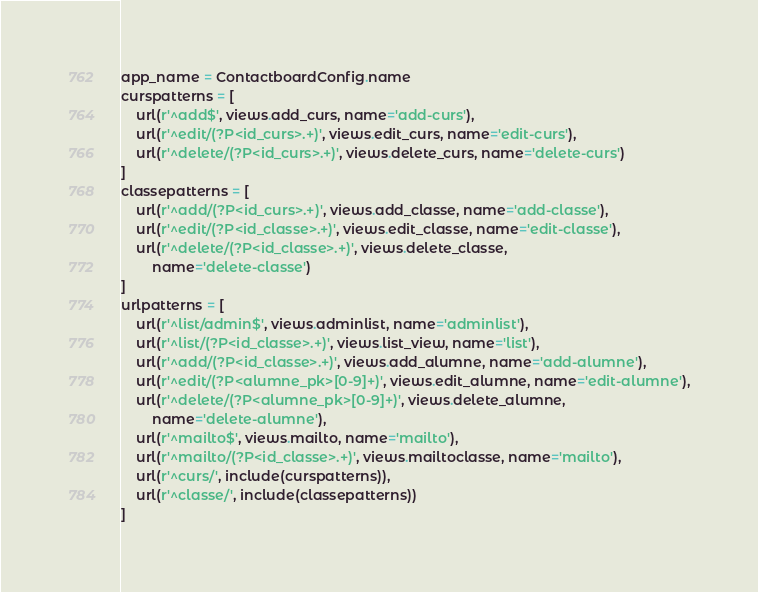Convert code to text. <code><loc_0><loc_0><loc_500><loc_500><_Python_>app_name = ContactboardConfig.name
curspatterns = [
    url(r'^add$', views.add_curs, name='add-curs'),
    url(r'^edit/(?P<id_curs>.+)', views.edit_curs, name='edit-curs'),
    url(r'^delete/(?P<id_curs>.+)', views.delete_curs, name='delete-curs')
]
classepatterns = [
    url(r'^add/(?P<id_curs>.+)', views.add_classe, name='add-classe'),
    url(r'^edit/(?P<id_classe>.+)', views.edit_classe, name='edit-classe'),
    url(r'^delete/(?P<id_classe>.+)', views.delete_classe,
        name='delete-classe')
]
urlpatterns = [
    url(r'^list/admin$', views.adminlist, name='adminlist'),
    url(r'^list/(?P<id_classe>.+)', views.list_view, name='list'),
    url(r'^add/(?P<id_classe>.+)', views.add_alumne, name='add-alumne'),
    url(r'^edit/(?P<alumne_pk>[0-9]+)', views.edit_alumne, name='edit-alumne'),
    url(r'^delete/(?P<alumne_pk>[0-9]+)', views.delete_alumne,
        name='delete-alumne'),
    url(r'^mailto$', views.mailto, name='mailto'),
    url(r'^mailto/(?P<id_classe>.+)', views.mailtoclasse, name='mailto'),
    url(r'^curs/', include(curspatterns)),
    url(r'^classe/', include(classepatterns))
]
</code> 